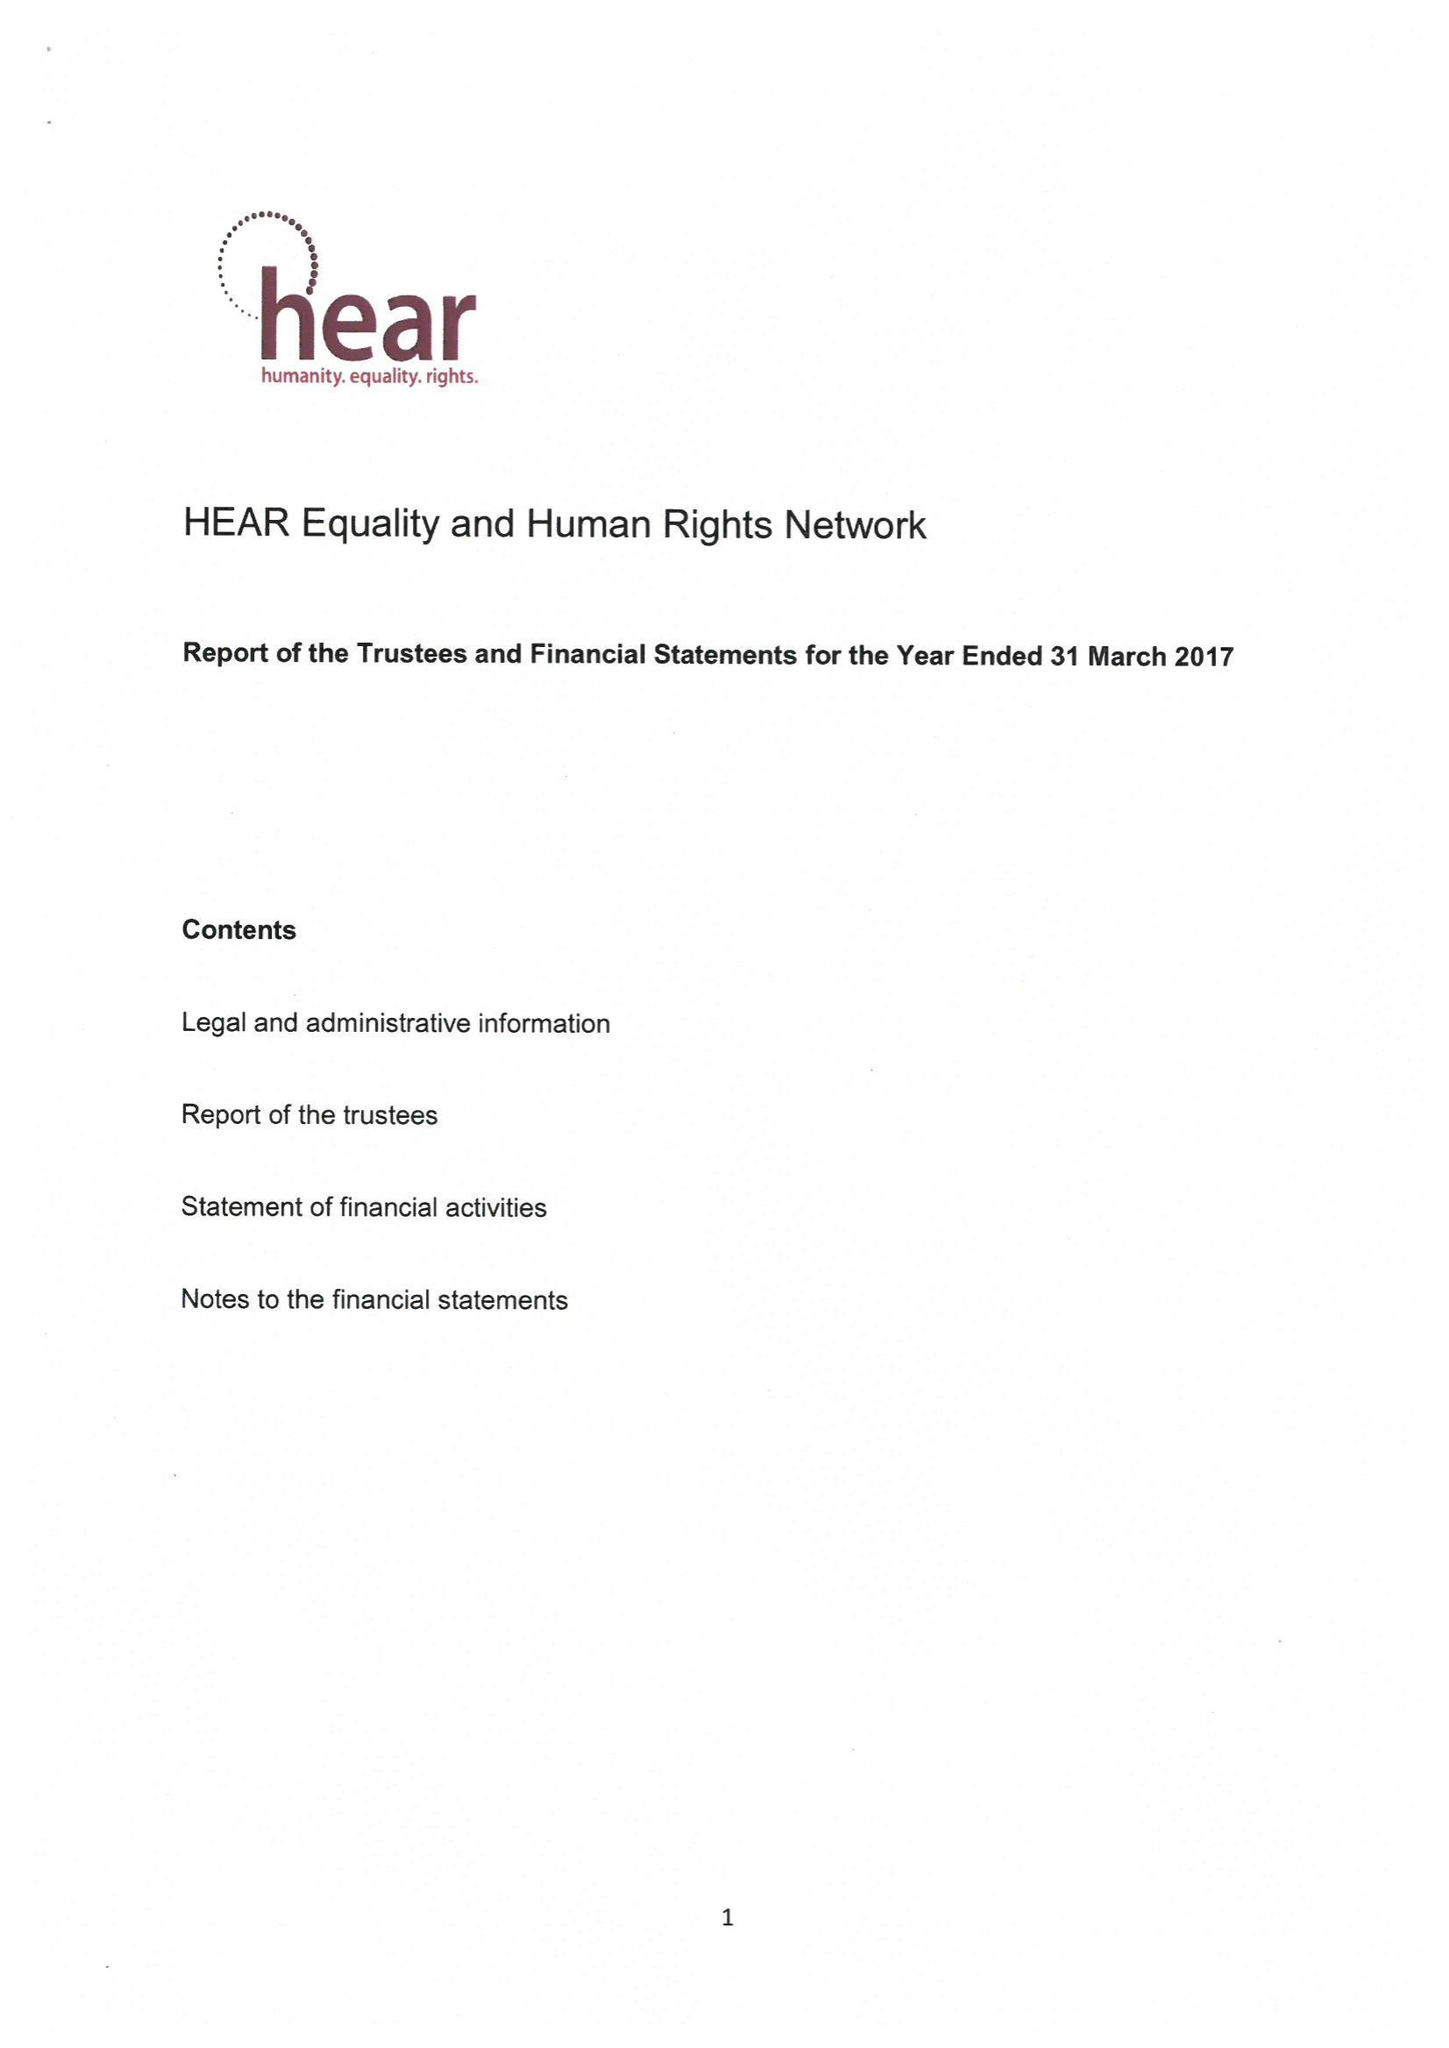What is the value for the charity_name?
Answer the question using a single word or phrase. Hear Equality and Human Rights Network 